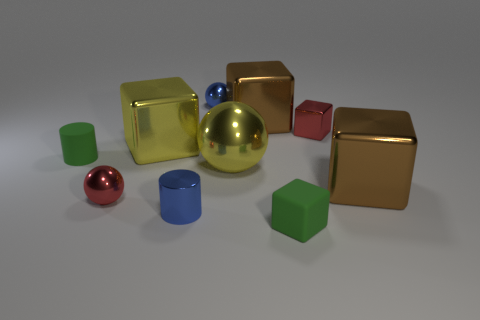Subtract all brown cubes. How many were subtracted if there are1brown cubes left? 1 Subtract all small metallic spheres. How many spheres are left? 1 Subtract all green cylinders. How many cylinders are left? 1 Subtract all cylinders. How many objects are left? 8 Subtract 1 balls. How many balls are left? 2 Subtract 0 yellow cylinders. How many objects are left? 10 Subtract all brown cylinders. Subtract all brown blocks. How many cylinders are left? 2 Subtract all yellow blocks. How many red spheres are left? 1 Subtract all big brown objects. Subtract all metal balls. How many objects are left? 5 Add 5 red metallic balls. How many red metallic balls are left? 6 